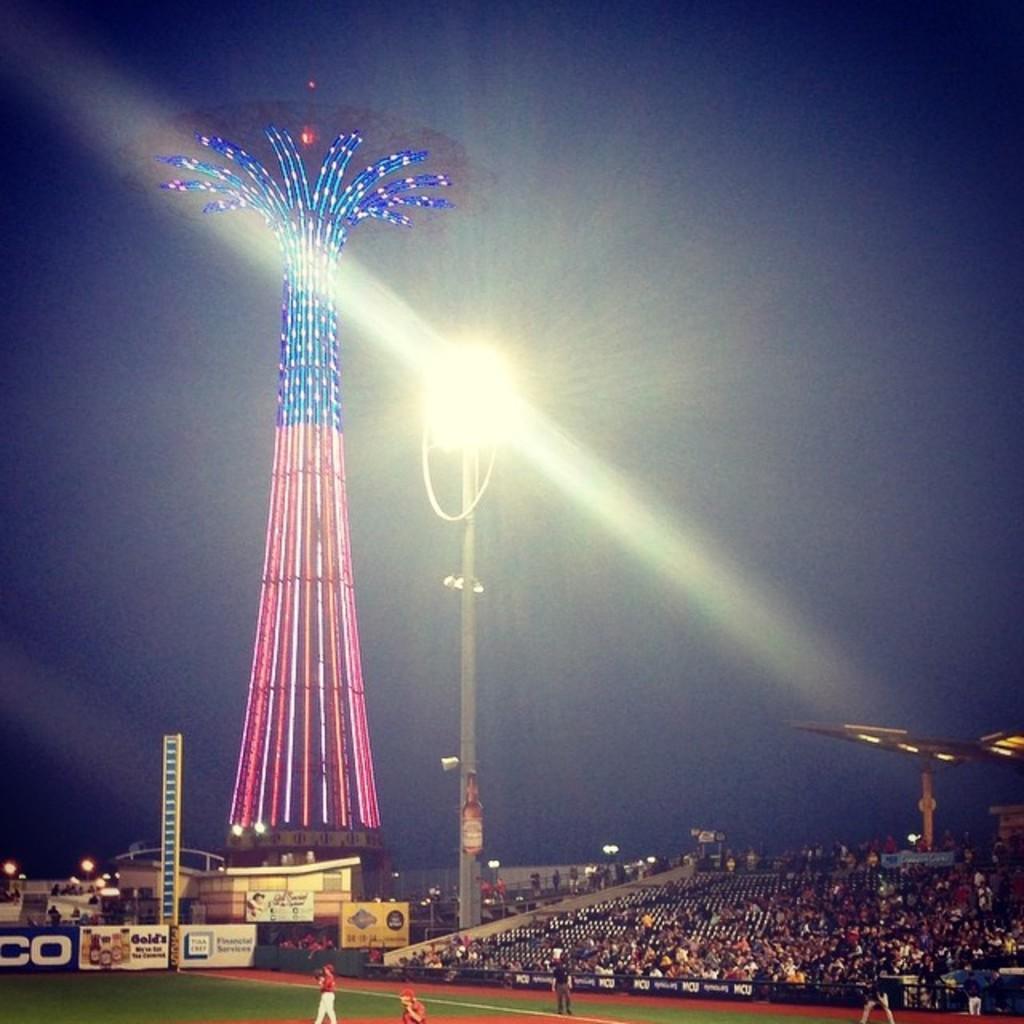Describe this image in one or two sentences. In this image there are group of people sitting on the chairs and standing on the ground in a stadium ,and in the background there are boards, lights, poles, a tower with lights, sky. 